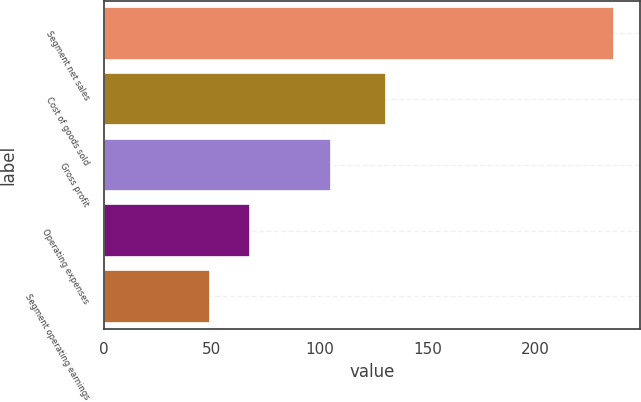Convert chart. <chart><loc_0><loc_0><loc_500><loc_500><bar_chart><fcel>Segment net sales<fcel>Cost of goods sold<fcel>Gross profit<fcel>Operating expenses<fcel>Segment operating earnings<nl><fcel>236.5<fcel>131<fcel>105.5<fcel>67.93<fcel>49.2<nl></chart> 